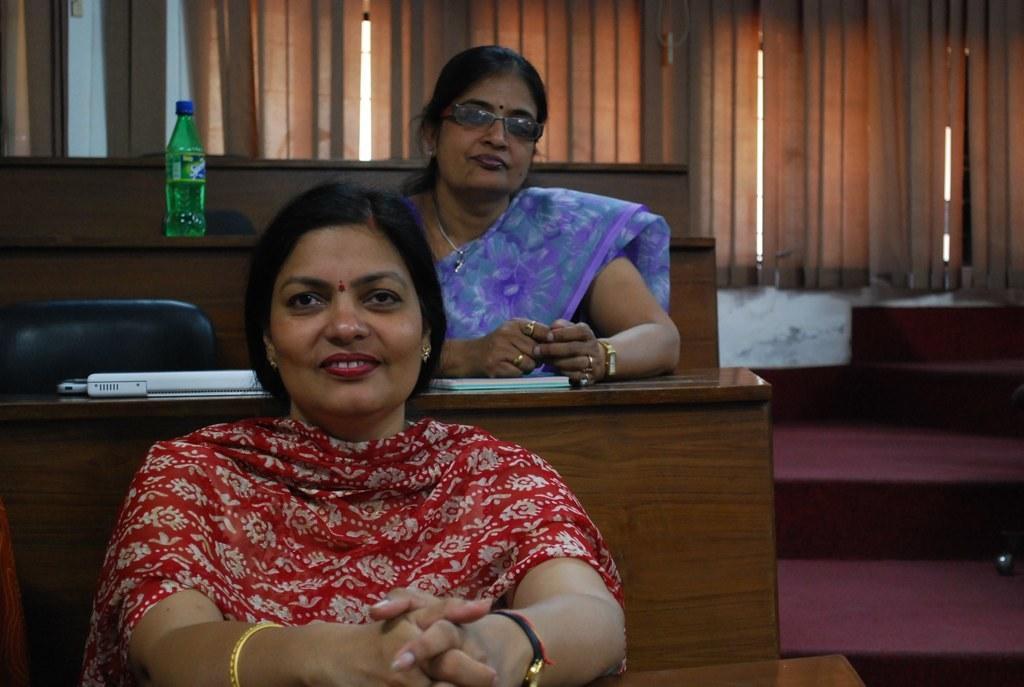Could you give a brief overview of what you see in this image? In this picture there is a lady who is sitting on the left side of the image, on the bench and there is another lady who is sitting in the center of the image, on the bench, there is a laptop and water bottle on the bench and there are stairs on the right side of the image and there are curtains at the top side of the image. 